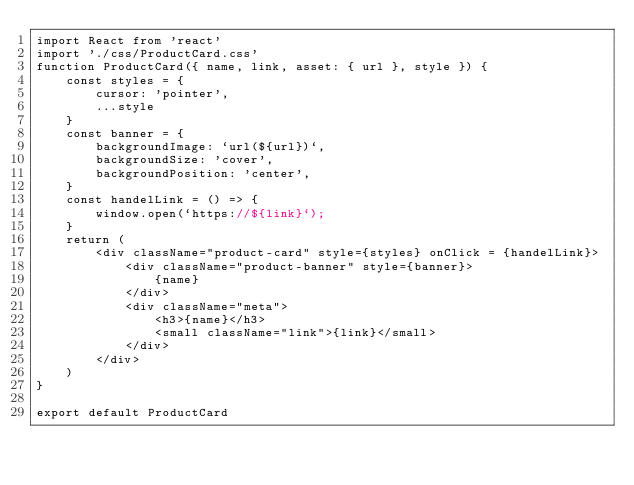Convert code to text. <code><loc_0><loc_0><loc_500><loc_500><_JavaScript_>import React from 'react'
import './css/ProductCard.css'
function ProductCard({ name, link, asset: { url }, style }) {
    const styles = {
        cursor: 'pointer',
        ...style
    }
    const banner = {
        backgroundImage: `url(${url})`,
        backgroundSize: 'cover',
        backgroundPosition: 'center',
    }
    const handelLink = () => {
        window.open(`https://${link}`);
    }
    return (
        <div className="product-card" style={styles} onClick = {handelLink}>
            <div className="product-banner" style={banner}>
                {name}
            </div>
            <div className="meta">
                <h3>{name}</h3>
                <small className="link">{link}</small>
            </div>
        </div>
    )
}

export default ProductCard
</code> 